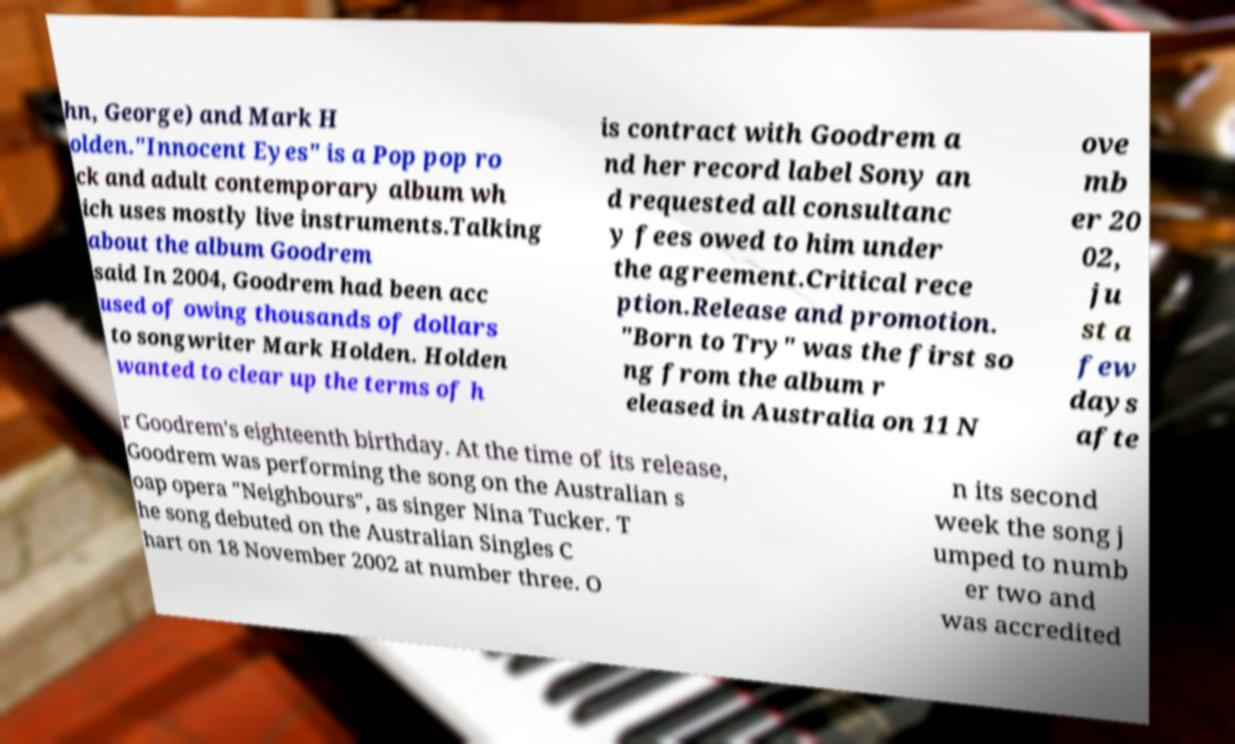What messages or text are displayed in this image? I need them in a readable, typed format. hn, George) and Mark H olden."Innocent Eyes" is a Pop pop ro ck and adult contemporary album wh ich uses mostly live instruments.Talking about the album Goodrem said In 2004, Goodrem had been acc used of owing thousands of dollars to songwriter Mark Holden. Holden wanted to clear up the terms of h is contract with Goodrem a nd her record label Sony an d requested all consultanc y fees owed to him under the agreement.Critical rece ption.Release and promotion. "Born to Try" was the first so ng from the album r eleased in Australia on 11 N ove mb er 20 02, ju st a few days afte r Goodrem's eighteenth birthday. At the time of its release, Goodrem was performing the song on the Australian s oap opera "Neighbours", as singer Nina Tucker. T he song debuted on the Australian Singles C hart on 18 November 2002 at number three. O n its second week the song j umped to numb er two and was accredited 